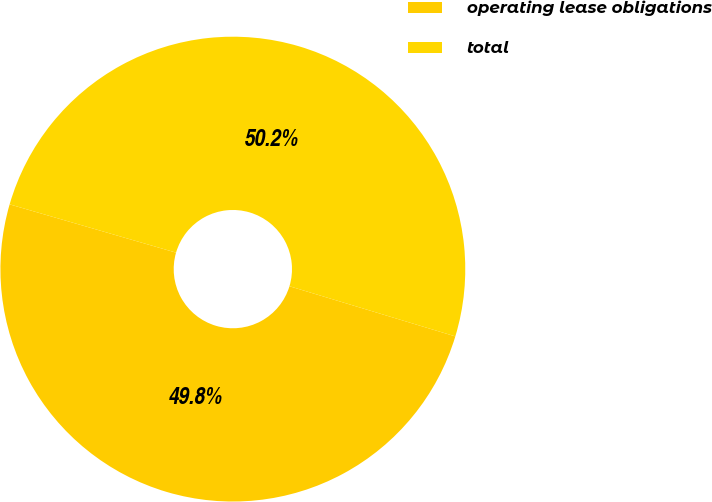<chart> <loc_0><loc_0><loc_500><loc_500><pie_chart><fcel>operating lease obligations<fcel>total<nl><fcel>49.82%<fcel>50.18%<nl></chart> 